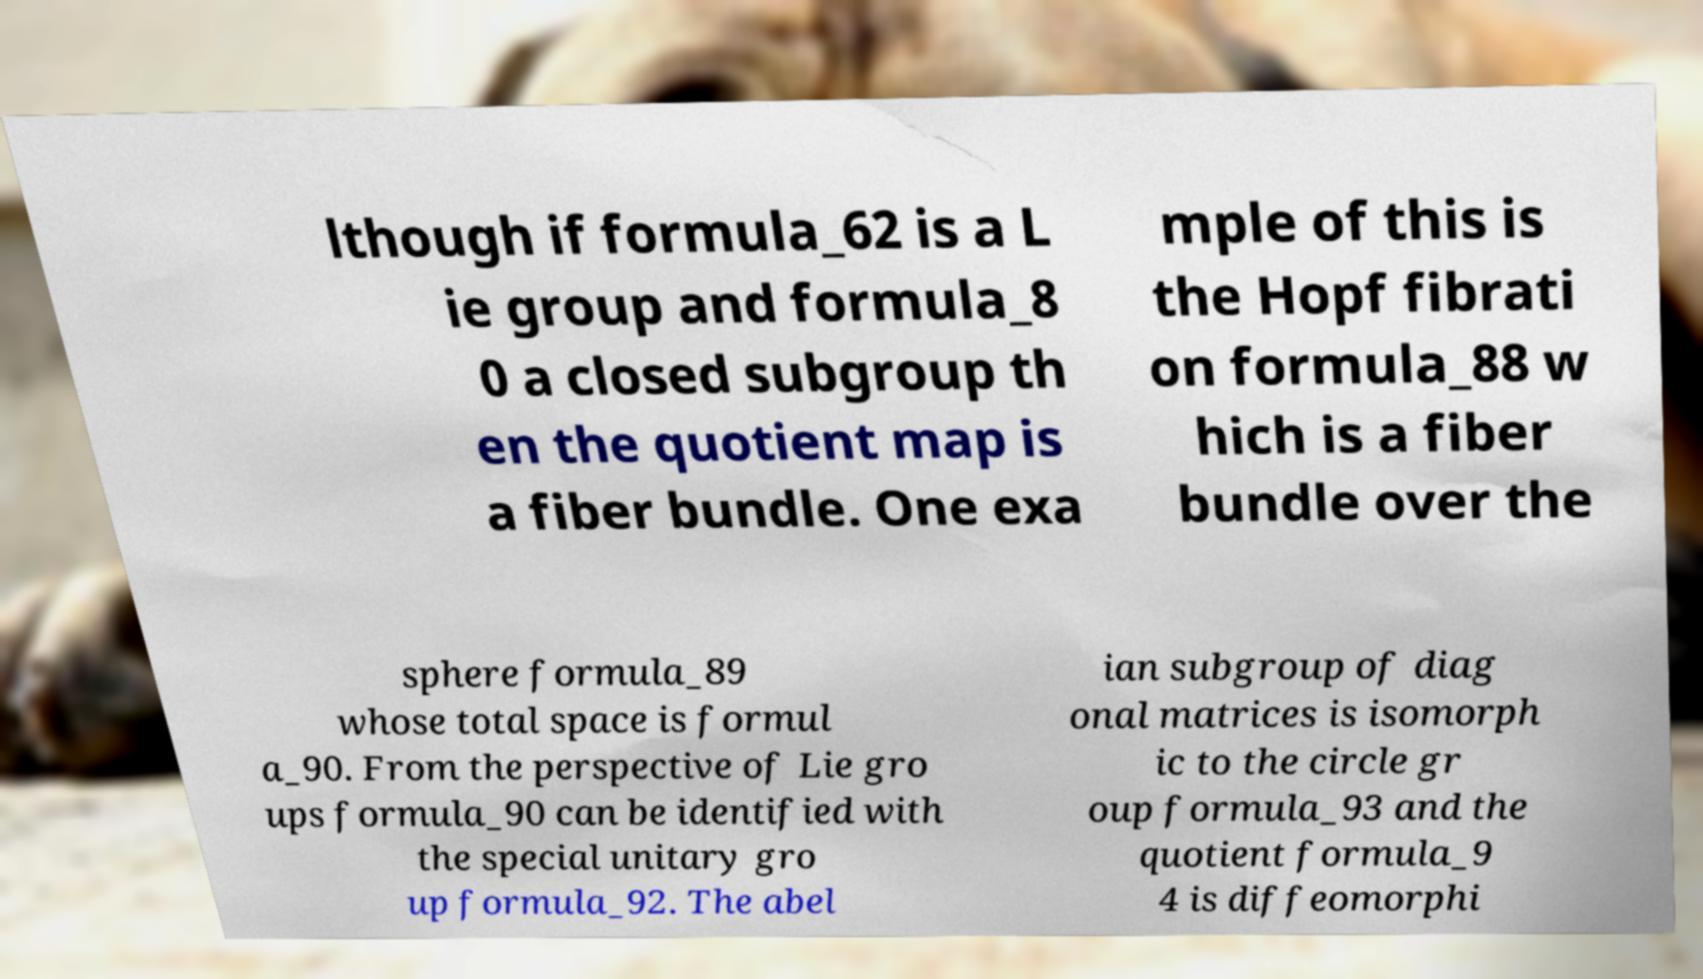Please read and relay the text visible in this image. What does it say? lthough if formula_62 is a L ie group and formula_8 0 a closed subgroup th en the quotient map is a fiber bundle. One exa mple of this is the Hopf fibrati on formula_88 w hich is a fiber bundle over the sphere formula_89 whose total space is formul a_90. From the perspective of Lie gro ups formula_90 can be identified with the special unitary gro up formula_92. The abel ian subgroup of diag onal matrices is isomorph ic to the circle gr oup formula_93 and the quotient formula_9 4 is diffeomorphi 